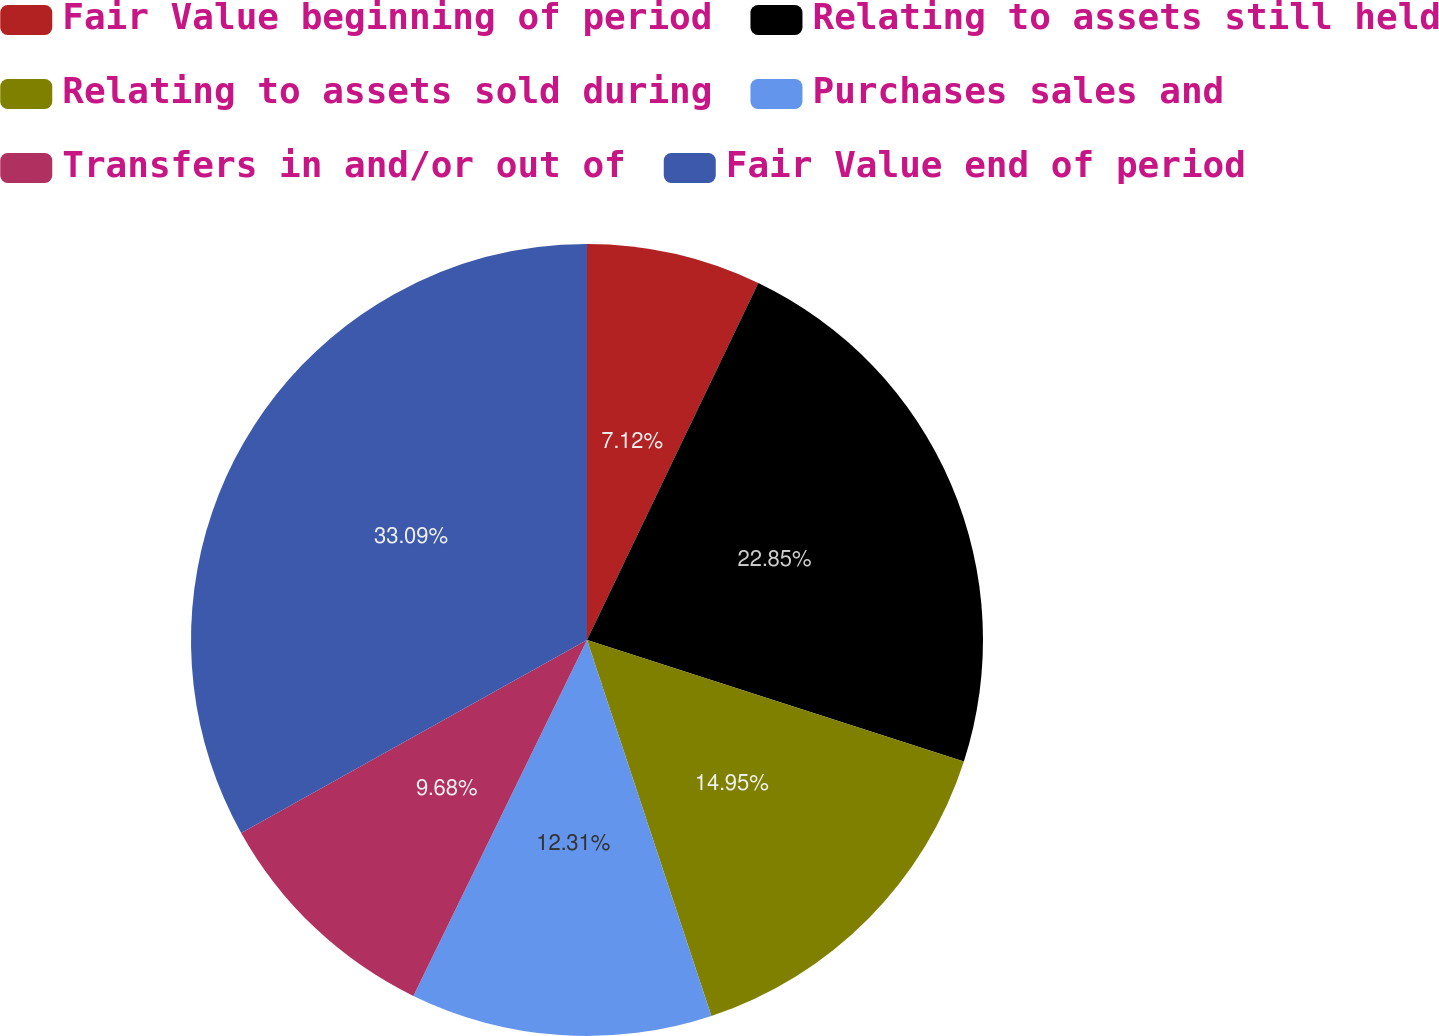Convert chart to OTSL. <chart><loc_0><loc_0><loc_500><loc_500><pie_chart><fcel>Fair Value beginning of period<fcel>Relating to assets still held<fcel>Relating to assets sold during<fcel>Purchases sales and<fcel>Transfers in and/or out of<fcel>Fair Value end of period<nl><fcel>7.12%<fcel>22.85%<fcel>14.95%<fcel>12.31%<fcel>9.68%<fcel>33.1%<nl></chart> 